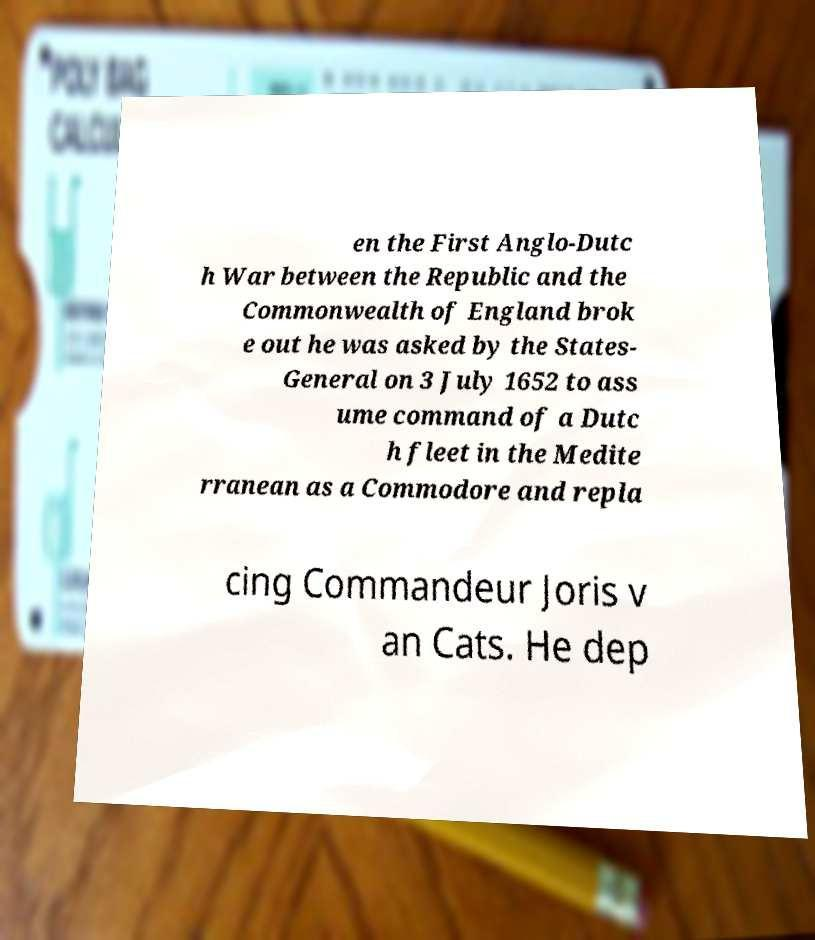Can you accurately transcribe the text from the provided image for me? en the First Anglo-Dutc h War between the Republic and the Commonwealth of England brok e out he was asked by the States- General on 3 July 1652 to ass ume command of a Dutc h fleet in the Medite rranean as a Commodore and repla cing Commandeur Joris v an Cats. He dep 